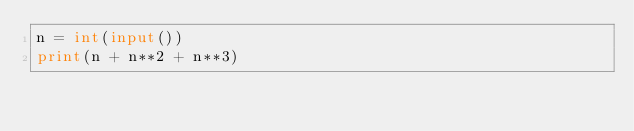Convert code to text. <code><loc_0><loc_0><loc_500><loc_500><_Python_>n = int(input())
print(n + n**2 + n**3)</code> 